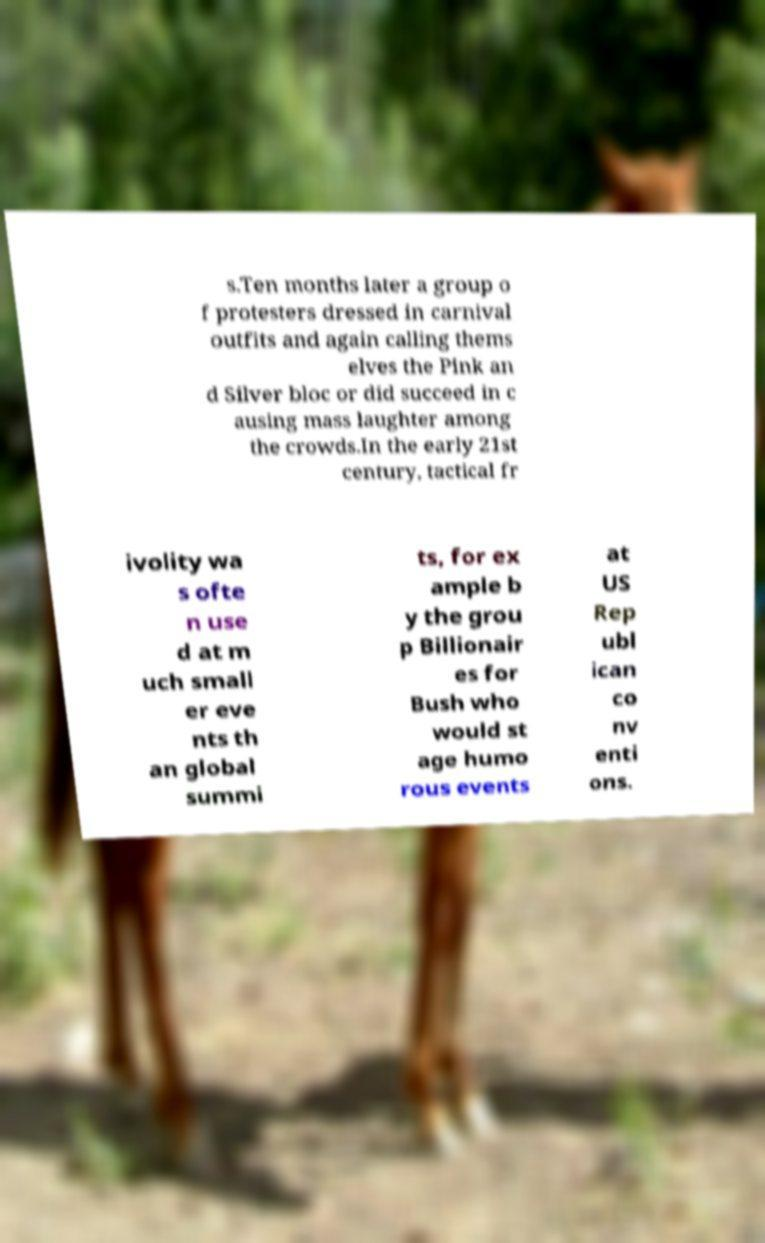Could you assist in decoding the text presented in this image and type it out clearly? s.Ten months later a group o f protesters dressed in carnival outfits and again calling thems elves the Pink an d Silver bloc or did succeed in c ausing mass laughter among the crowds.In the early 21st century, tactical fr ivolity wa s ofte n use d at m uch small er eve nts th an global summi ts, for ex ample b y the grou p Billionair es for Bush who would st age humo rous events at US Rep ubl ican co nv enti ons. 